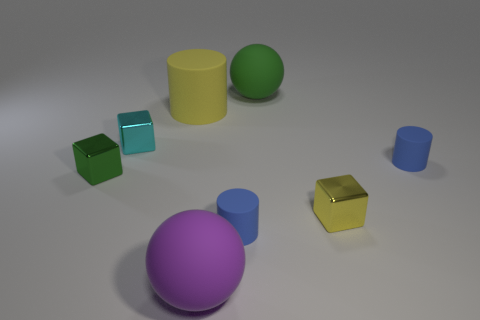What number of things are large green spheres or tiny metallic blocks left of the large yellow rubber object?
Your answer should be very brief. 3. How many other objects are the same shape as the yellow metallic object?
Offer a terse response. 2. Is the number of big yellow cylinders that are behind the tiny yellow shiny thing less than the number of matte objects that are in front of the green rubber sphere?
Ensure brevity in your answer.  Yes. There is a yellow object that is the same material as the large green sphere; what is its shape?
Offer a terse response. Cylinder. What color is the small cylinder that is to the left of the rubber thing right of the big green sphere?
Provide a short and direct response. Blue. What material is the tiny block on the right side of the small cylinder in front of the green object that is in front of the big green sphere made of?
Your response must be concise. Metal. How many green spheres are the same size as the yellow matte object?
Keep it short and to the point. 1. There is a cube that is in front of the tiny cyan metallic thing and left of the large green thing; what material is it?
Keep it short and to the point. Metal. There is a large purple thing; what number of blue matte things are behind it?
Offer a very short reply. 2. There is a cyan shiny object; does it have the same shape as the small shiny object in front of the green shiny block?
Your answer should be very brief. Yes. 